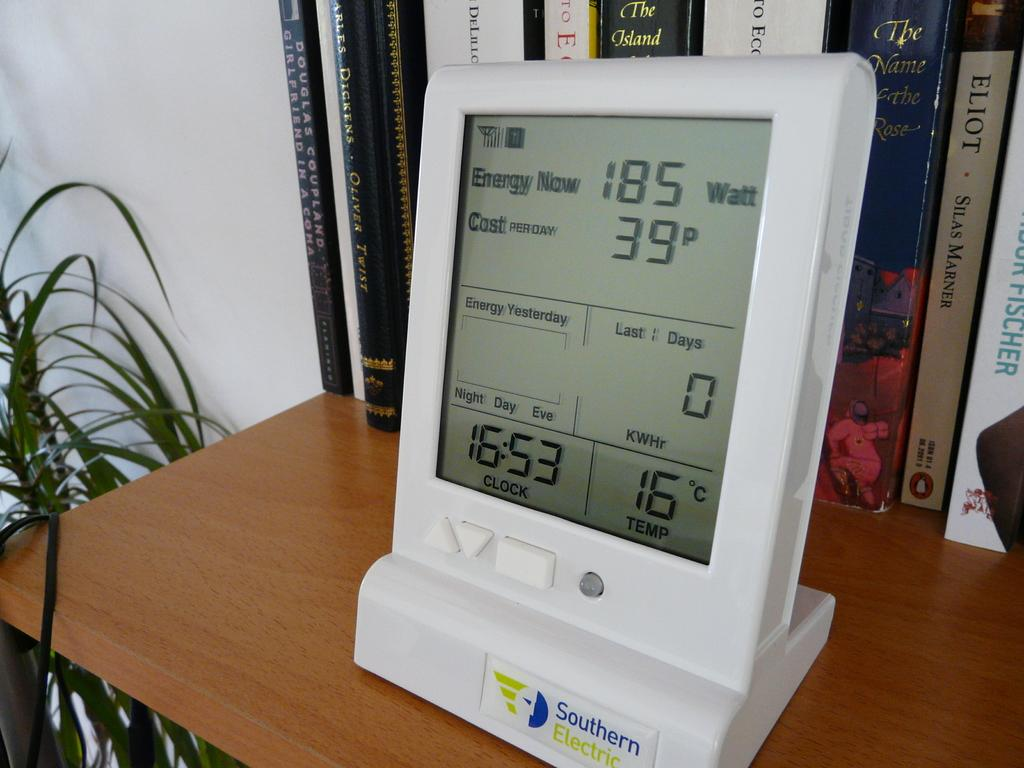<image>
Give a short and clear explanation of the subsequent image. A digital display on a shelf that reads various daily energy consumption information and a current time of 16:53 on it's clock 